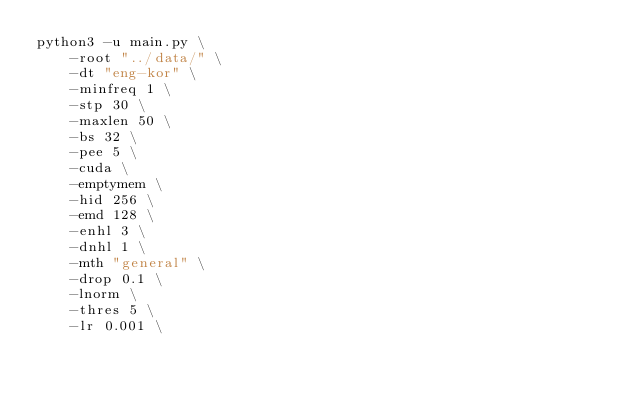<code> <loc_0><loc_0><loc_500><loc_500><_Bash_>python3 -u main.py \
    -root "../data/" \
    -dt "eng-kor" \
    -minfreq 1 \
    -stp 30 \
    -maxlen 50 \
    -bs 32 \
    -pee 5 \
    -cuda \
    -emptymem \
    -hid 256 \
    -emd 128 \
    -enhl 3 \
    -dnhl 1 \
    -mth "general" \
    -drop 0.1 \
    -lnorm \
    -thres 5 \
    -lr 0.001 \</code> 